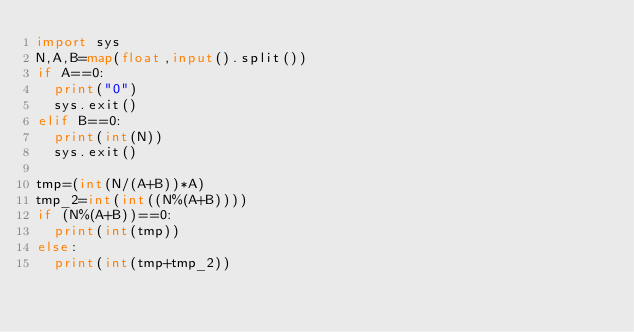Convert code to text. <code><loc_0><loc_0><loc_500><loc_500><_Python_>import sys
N,A,B=map(float,input().split())
if A==0:
  print("0")
  sys.exit()
elif B==0:
  print(int(N))
  sys.exit()

tmp=(int(N/(A+B))*A)
tmp_2=int(int((N%(A+B))))
if (N%(A+B))==0:
  print(int(tmp))
else:
  print(int(tmp+tmp_2))
</code> 